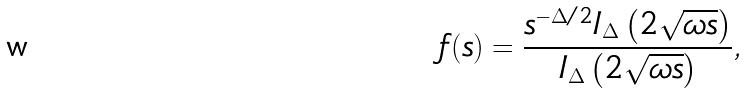Convert formula to latex. <formula><loc_0><loc_0><loc_500><loc_500>f ( s ) = \frac { s ^ { - \Delta / 2 } I _ { \Delta } \left ( 2 \sqrt { \omega s } \right ) } { I _ { \Delta } \left ( 2 \sqrt { \omega s } \right ) } ,</formula> 